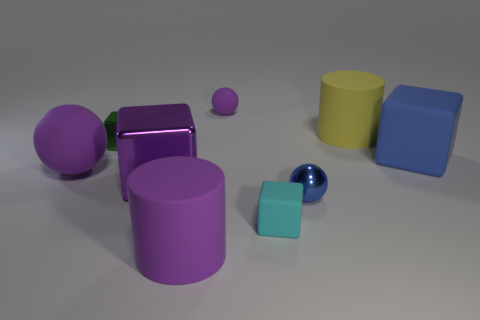There is a metallic thing behind the big rubber sphere; what is its shape?
Your answer should be very brief. Cube. What is the size of the blue thing that is the same material as the large purple sphere?
Keep it short and to the point. Large. What number of large blue objects are the same shape as the small purple rubber object?
Give a very brief answer. 0. There is a tiny thing that is to the left of the large purple shiny thing; does it have the same color as the large sphere?
Offer a very short reply. No. There is a ball that is in front of the rubber ball in front of the small green shiny object; how many tiny green shiny blocks are on the left side of it?
Your answer should be very brief. 1. How many matte cylinders are both in front of the tiny rubber cube and behind the large purple sphere?
Ensure brevity in your answer.  0. There is a big thing that is the same color as the small metallic ball; what shape is it?
Keep it short and to the point. Cube. Are there any other things that have the same material as the small green object?
Give a very brief answer. Yes. Do the yellow object and the large blue thing have the same material?
Give a very brief answer. Yes. What is the shape of the small shiny thing on the right side of the tiny purple ball to the right of the big rubber cylinder in front of the blue matte block?
Offer a terse response. Sphere. 